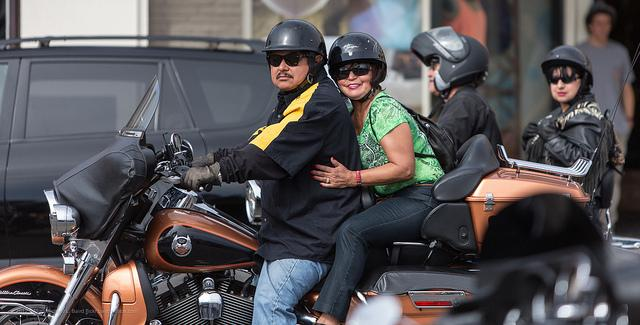Who is the happiest in the picture? woman 